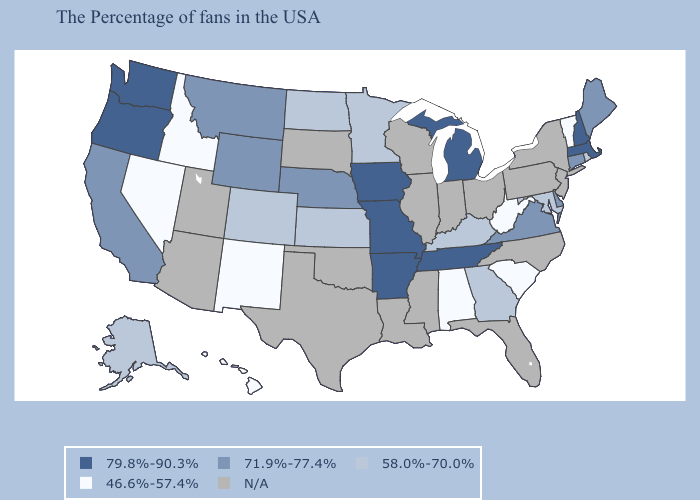Name the states that have a value in the range N/A?
Keep it brief. New York, New Jersey, Pennsylvania, North Carolina, Ohio, Florida, Indiana, Wisconsin, Illinois, Mississippi, Louisiana, Oklahoma, Texas, South Dakota, Utah, Arizona. How many symbols are there in the legend?
Keep it brief. 5. Does North Dakota have the lowest value in the MidWest?
Write a very short answer. Yes. How many symbols are there in the legend?
Short answer required. 5. Which states have the lowest value in the USA?
Answer briefly. Vermont, South Carolina, West Virginia, Alabama, New Mexico, Idaho, Nevada, Hawaii. Name the states that have a value in the range 79.8%-90.3%?
Answer briefly. Massachusetts, New Hampshire, Michigan, Tennessee, Missouri, Arkansas, Iowa, Washington, Oregon. Name the states that have a value in the range 58.0%-70.0%?
Write a very short answer. Rhode Island, Maryland, Georgia, Kentucky, Minnesota, Kansas, North Dakota, Colorado, Alaska. What is the value of California?
Be succinct. 71.9%-77.4%. Name the states that have a value in the range 71.9%-77.4%?
Be succinct. Maine, Connecticut, Delaware, Virginia, Nebraska, Wyoming, Montana, California. Among the states that border Mississippi , does Arkansas have the lowest value?
Concise answer only. No. Among the states that border Florida , which have the highest value?
Be succinct. Georgia. Does Michigan have the highest value in the MidWest?
Concise answer only. Yes. What is the highest value in the USA?
Quick response, please. 79.8%-90.3%. 